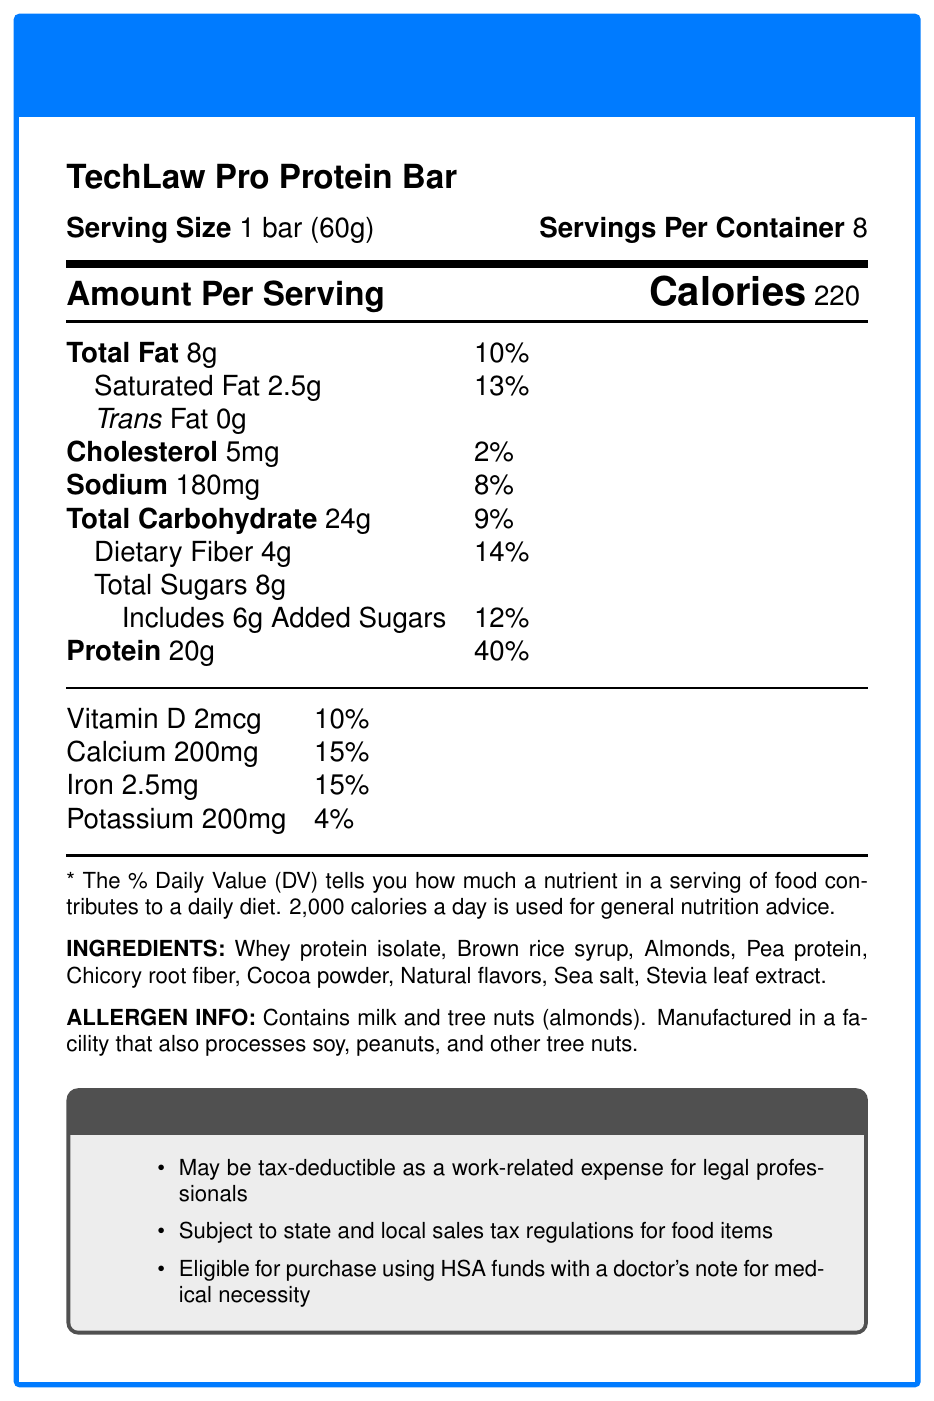what is the serving size? The serving size is clearly stated at the beginning of the document as "1 bar (60g)".
Answer: 1 bar (60g) how many calories are there per serving? The document specifies "Calories 220" under the section "Amount Per Serving".
Answer: 220 how much protein is in one serving? The protein amount is listed as "20g" in the nutritional information.
Answer: 20g what is the total fat content? The total fat content per serving is provided as "Total Fat 8g".
Answer: 8g how many servings are in a container? The number of servings per container is listed as "Servings Per Container 8".
Answer: 8 what allergens are present in the TechLaw Pro Protein Bar? The allergen information states it contains "milk and tree nuts (almonds)".
Answer: Milk and tree nuts (almonds) is the bar subject to sales tax regulations? The tax implications section mentions "Subject to state and local sales tax regulations for food items".
Answer: Yes which ingredient is used as a natural sweetener? The ingredient list includes "Stevia leaf extract" which is used as a natural sweetener.
Answer: Stevia leaf extract which mineral has the highest daily value percentage in the protein bar? A. Vitamin D B. Calcium C. Iron D. Potassium Calcium has the highest daily value percentage at 15%, shared with Iron but Calcium is listed higher in the nutritional information.
Answer: B what are the benefits of the TechLaw Pro Protein Bar for busy law students and professionals? A. High in carbohydrates B. Low in protein C. Supports cognitive function D. Contains high sugar content One of the marketing claims is "20g of high-quality protein to support cognitive function during long study sessions".
Answer: C does the protein bar contain any gluten? The document does not provide any information about gluten content.
Answer: Not enough information summarize the main idea of the document. The document outlines key information about the TechLaw Pro Protein Bar, including its nutritional content, ingredients, allergen warnings, potential tax deductions, and its marketed benefits aimed at supporting professionals in mentally demanding and busy environments.
Answer: The document provides detailed nutritional information, ingredient list, allergen information, and tax implications for the TechLaw Pro Protein Bar, emphasizing its high protein content and benefits for busy professionals and law students. 